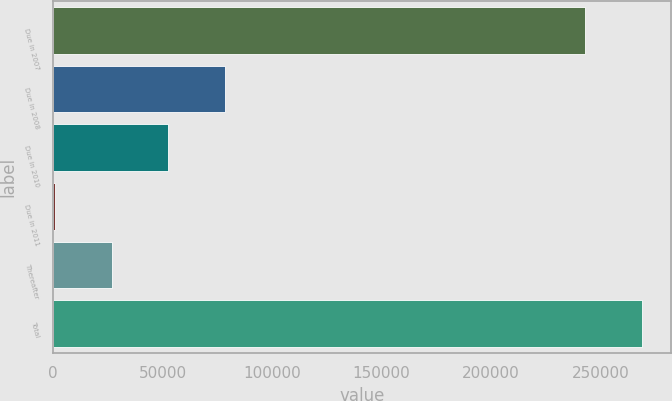Convert chart. <chart><loc_0><loc_0><loc_500><loc_500><bar_chart><fcel>Due in 2007<fcel>Due in 2008<fcel>Due in 2010<fcel>Due in 2011<fcel>Thereafter<fcel>Total<nl><fcel>242905<fcel>78605.6<fcel>52673.4<fcel>809<fcel>26741.2<fcel>268837<nl></chart> 